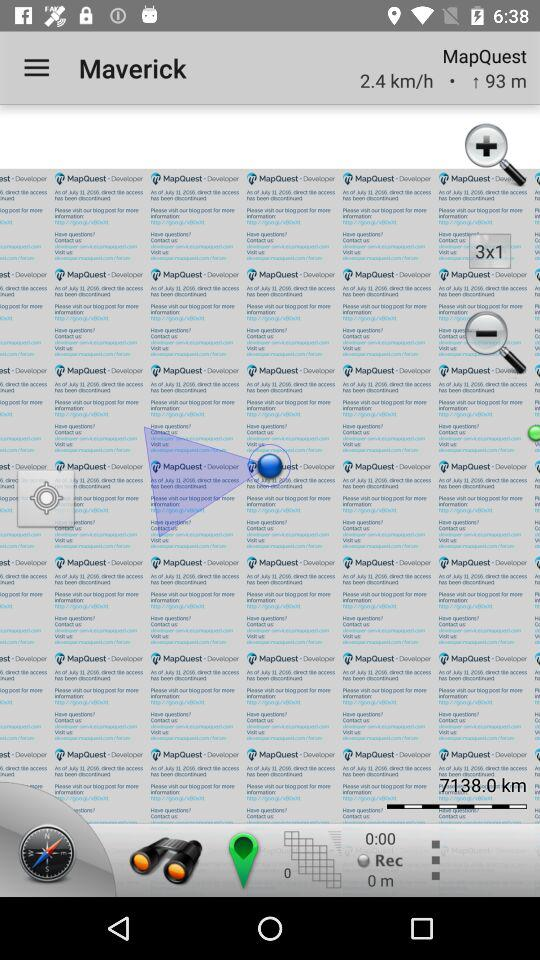How many kilometers are shown? The shown kilometers are 7138. 